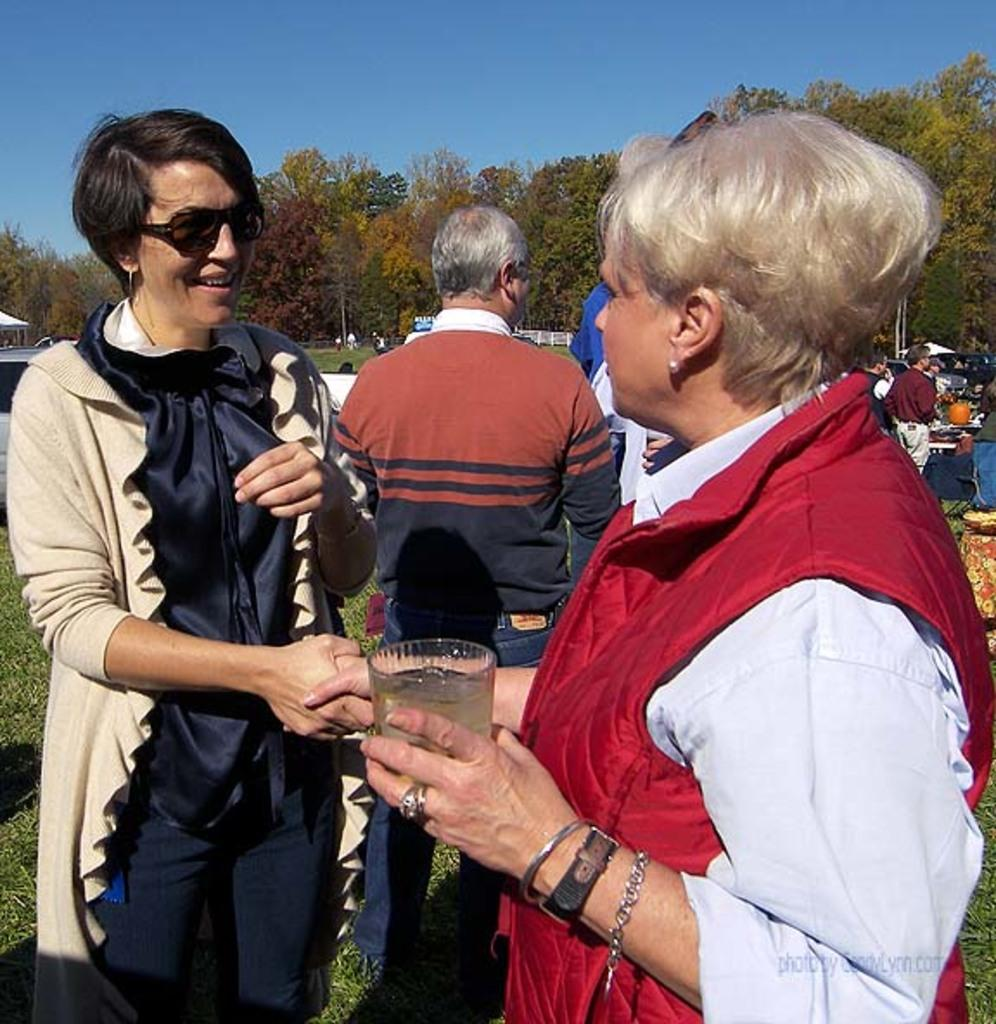How many people are in the image? There are three persons in the image. What are the people in the image doing? The persons are standing. Can you describe what the man is holding? The man is holding a glass. What can be seen in the background of the image? There is grass, persons, trees, and the sky visible in the background of the image. What type of powder is being used in the argument between the persons in the image? There is no argument or powder present in the image; the persons are simply standing. 